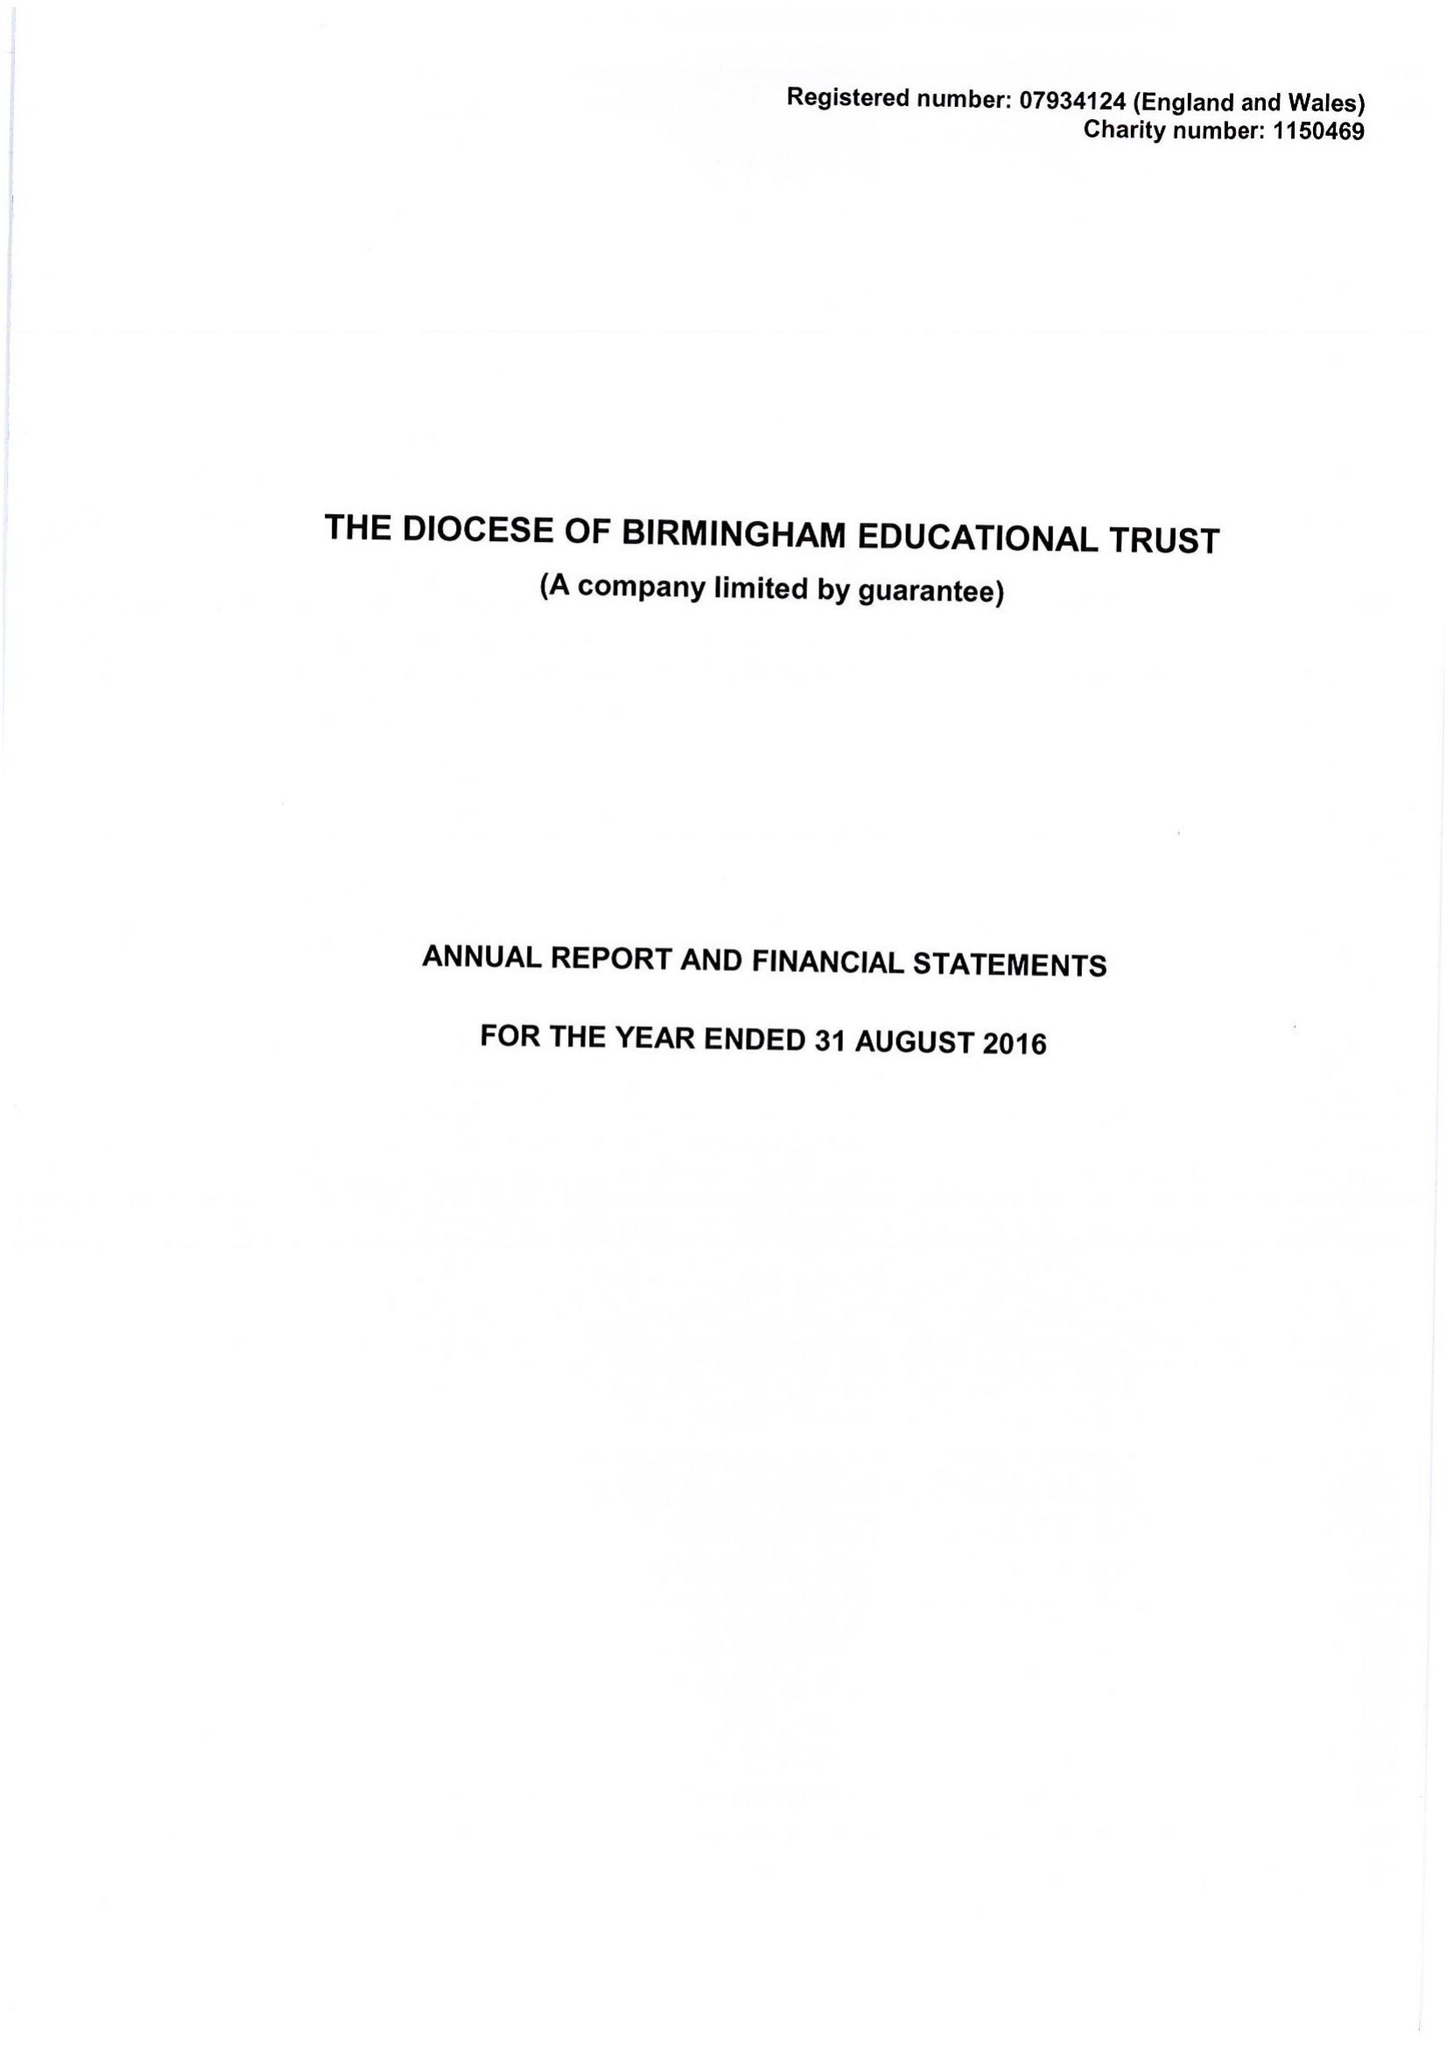What is the value for the address__post_town?
Answer the question using a single word or phrase. BIRMINGHAM 